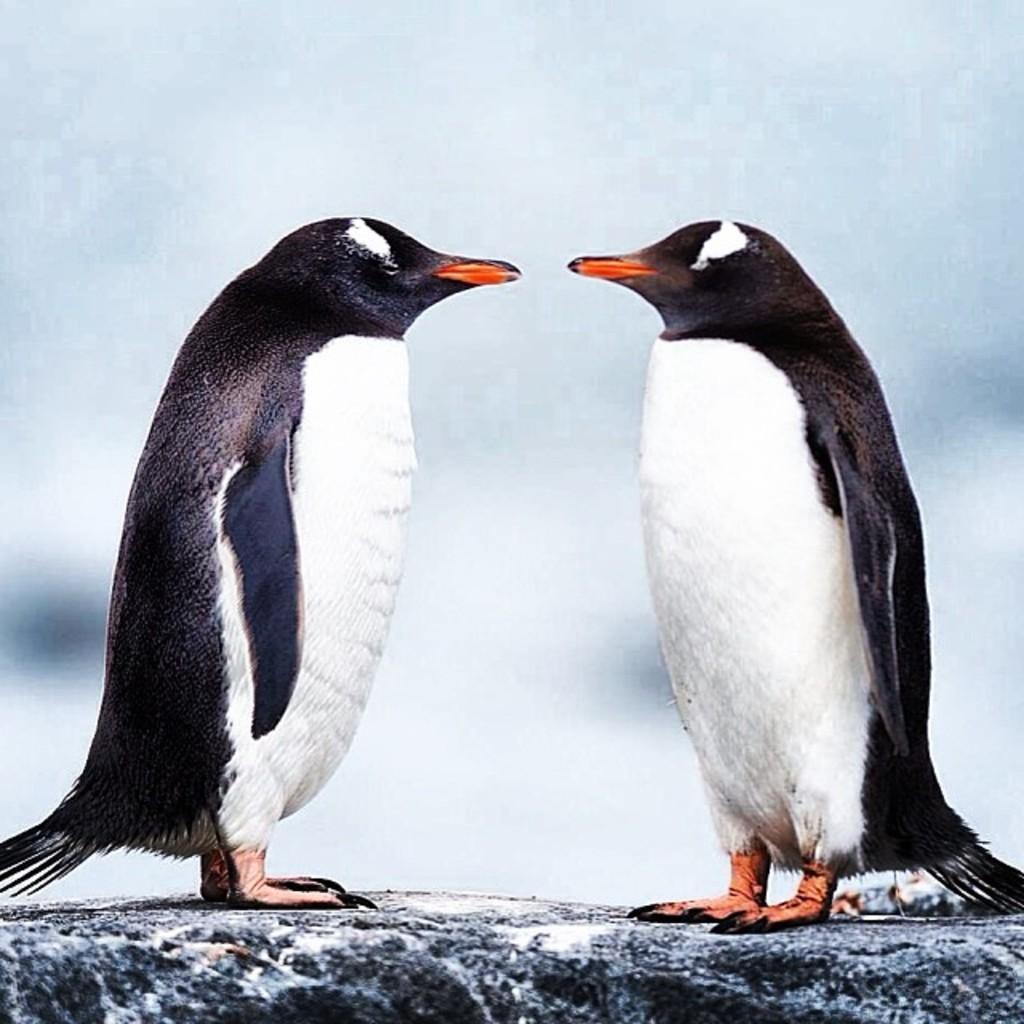How would you summarize this image in a sentence or two? In this image there are two penguins. 